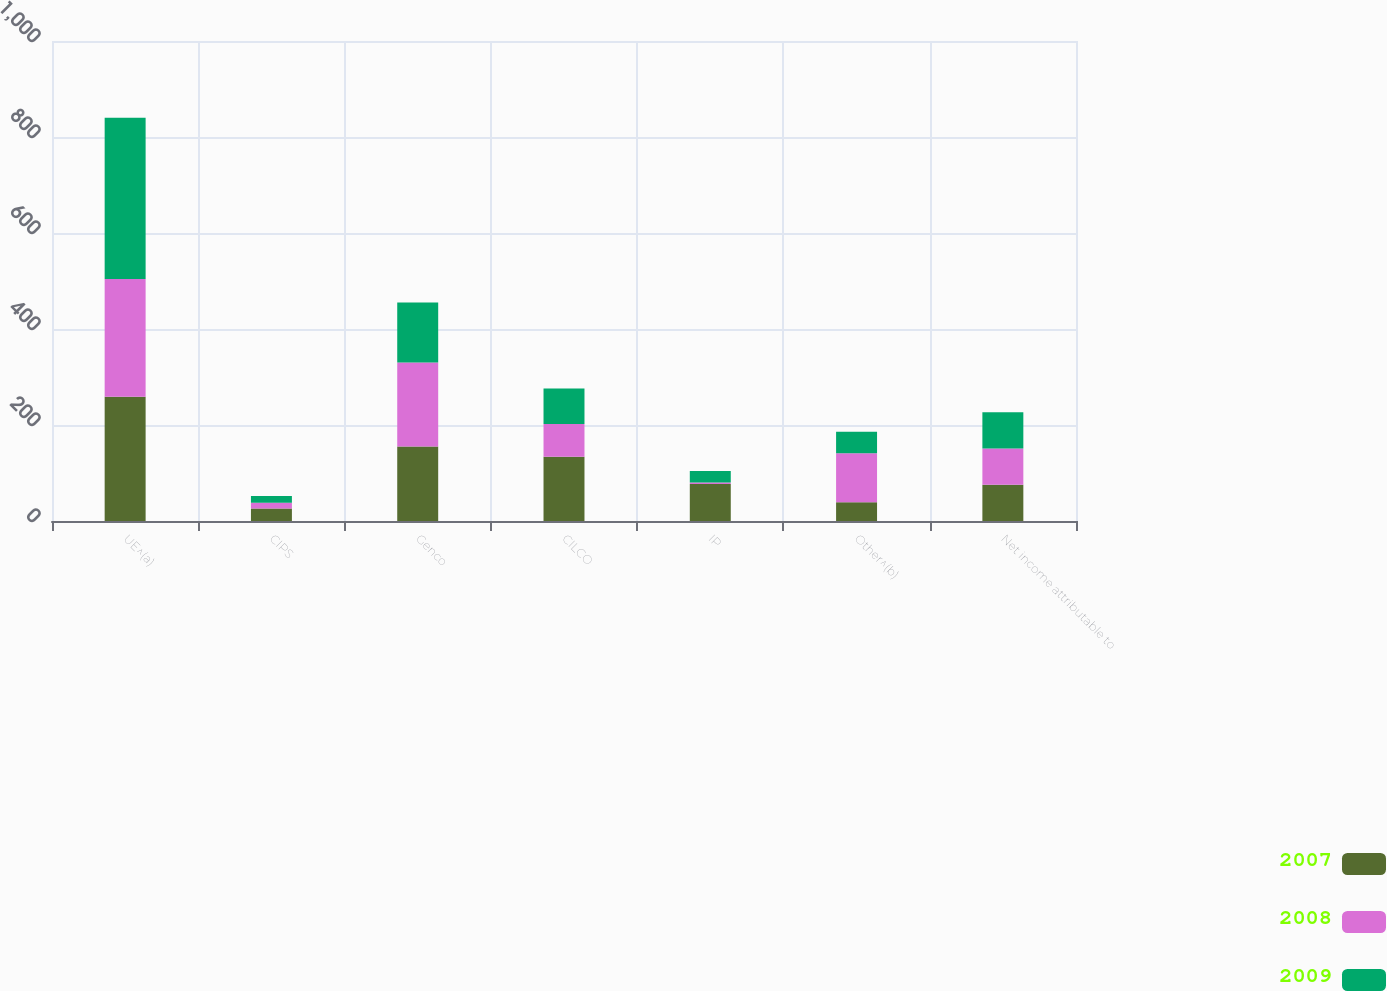<chart> <loc_0><loc_0><loc_500><loc_500><stacked_bar_chart><ecel><fcel>UE^(a)<fcel>CIPS<fcel>Genco<fcel>CILCO<fcel>IP<fcel>Other^(b)<fcel>Net income attributable to<nl><fcel>2007<fcel>259<fcel>26<fcel>155<fcel>134<fcel>77<fcel>39<fcel>75.5<nl><fcel>2008<fcel>245<fcel>12<fcel>175<fcel>68<fcel>3<fcel>102<fcel>75.5<nl><fcel>2009<fcel>336<fcel>14<fcel>125<fcel>74<fcel>24<fcel>45<fcel>75.5<nl></chart> 